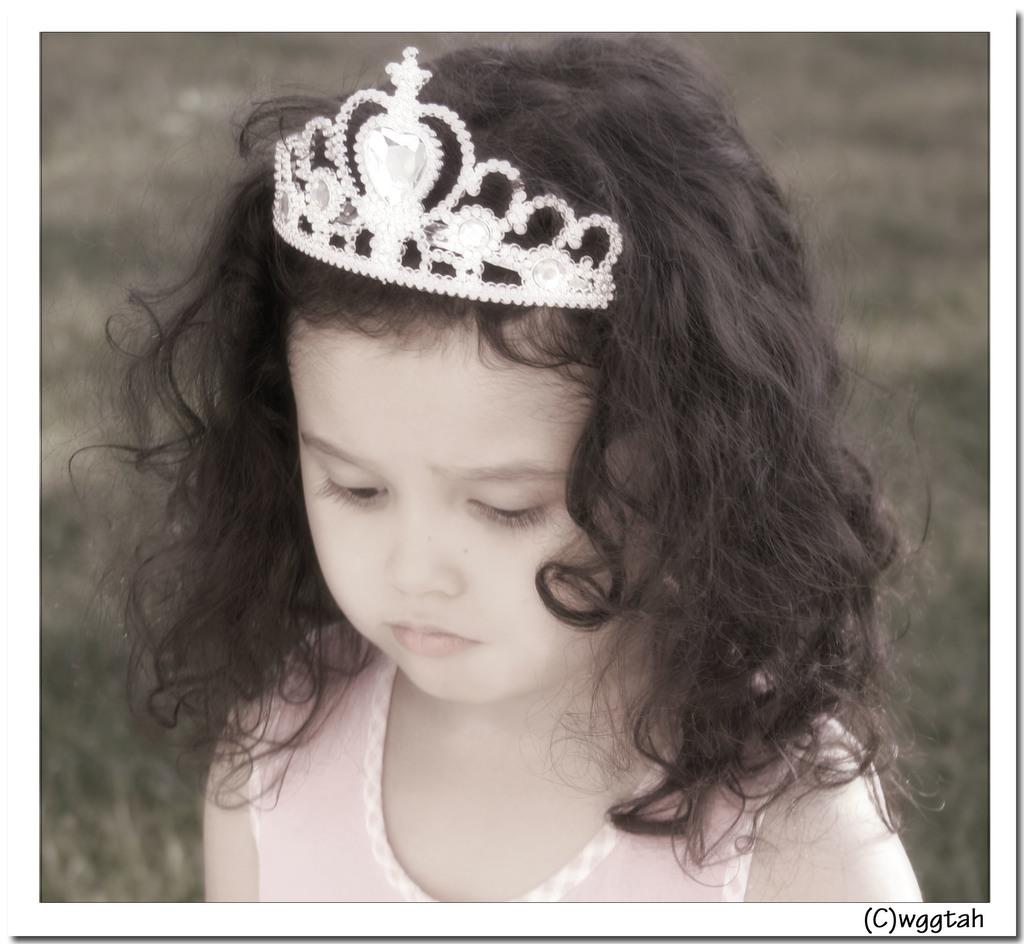Who is the main subject in the image? There is a girl in the center of the image. What is the girl wearing on her head? The girl is wearing a crown on her head. Can you describe the background of the image? The background of the image is blurry. What type of government is depicted in the image? There is no depiction of a government in the image; it features a girl wearing a crown. What is the base material of the crown the girl is wearing? The image does not provide enough detail to determine the base material of the crown. 